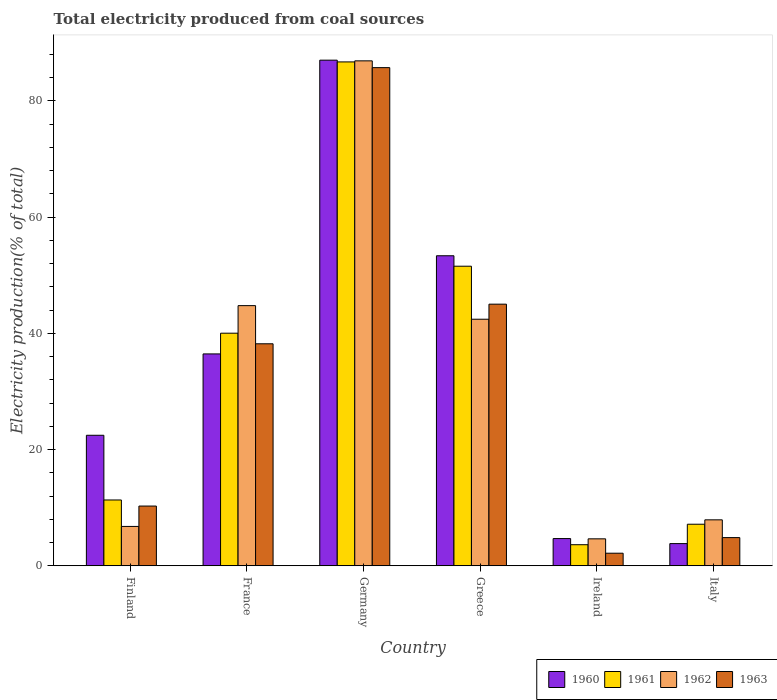What is the total electricity produced in 1962 in Germany?
Offer a terse response. 86.91. Across all countries, what is the maximum total electricity produced in 1962?
Provide a short and direct response. 86.91. Across all countries, what is the minimum total electricity produced in 1963?
Offer a terse response. 2.16. In which country was the total electricity produced in 1963 minimum?
Give a very brief answer. Ireland. What is the total total electricity produced in 1962 in the graph?
Offer a terse response. 193.45. What is the difference between the total electricity produced in 1962 in Finland and that in Ireland?
Offer a terse response. 2.13. What is the difference between the total electricity produced in 1963 in Ireland and the total electricity produced in 1962 in France?
Provide a short and direct response. -42.61. What is the average total electricity produced in 1961 per country?
Provide a succinct answer. 33.41. What is the difference between the total electricity produced of/in 1962 and total electricity produced of/in 1961 in France?
Offer a very short reply. 4.74. What is the ratio of the total electricity produced in 1960 in Germany to that in Italy?
Provide a succinct answer. 22.79. Is the difference between the total electricity produced in 1962 in Finland and Ireland greater than the difference between the total electricity produced in 1961 in Finland and Ireland?
Keep it short and to the point. No. What is the difference between the highest and the second highest total electricity produced in 1962?
Your answer should be very brief. -2.34. What is the difference between the highest and the lowest total electricity produced in 1963?
Provide a succinct answer. 83.58. In how many countries, is the total electricity produced in 1960 greater than the average total electricity produced in 1960 taken over all countries?
Offer a very short reply. 3. Is it the case that in every country, the sum of the total electricity produced in 1962 and total electricity produced in 1960 is greater than the sum of total electricity produced in 1963 and total electricity produced in 1961?
Make the answer very short. No. What does the 4th bar from the left in Germany represents?
Make the answer very short. 1963. Are all the bars in the graph horizontal?
Provide a succinct answer. No. What is the difference between two consecutive major ticks on the Y-axis?
Your response must be concise. 20. Does the graph contain grids?
Keep it short and to the point. No. How many legend labels are there?
Offer a terse response. 4. How are the legend labels stacked?
Offer a terse response. Horizontal. What is the title of the graph?
Ensure brevity in your answer.  Total electricity produced from coal sources. Does "1971" appear as one of the legend labels in the graph?
Make the answer very short. No. What is the label or title of the X-axis?
Provide a succinct answer. Country. What is the label or title of the Y-axis?
Your response must be concise. Electricity production(% of total). What is the Electricity production(% of total) of 1960 in Finland?
Your answer should be very brief. 22.46. What is the Electricity production(% of total) of 1961 in Finland?
Give a very brief answer. 11.33. What is the Electricity production(% of total) of 1962 in Finland?
Your answer should be compact. 6.78. What is the Electricity production(% of total) of 1963 in Finland?
Provide a succinct answer. 10.28. What is the Electricity production(% of total) in 1960 in France?
Keep it short and to the point. 36.47. What is the Electricity production(% of total) of 1961 in France?
Offer a very short reply. 40.03. What is the Electricity production(% of total) of 1962 in France?
Give a very brief answer. 44.78. What is the Electricity production(% of total) of 1963 in France?
Your response must be concise. 38.21. What is the Electricity production(% of total) of 1960 in Germany?
Your response must be concise. 87.03. What is the Electricity production(% of total) of 1961 in Germany?
Your answer should be compact. 86.73. What is the Electricity production(% of total) of 1962 in Germany?
Provide a short and direct response. 86.91. What is the Electricity production(% of total) of 1963 in Germany?
Your response must be concise. 85.74. What is the Electricity production(% of total) in 1960 in Greece?
Make the answer very short. 53.36. What is the Electricity production(% of total) in 1961 in Greece?
Your answer should be very brief. 51.56. What is the Electricity production(% of total) of 1962 in Greece?
Your response must be concise. 42.44. What is the Electricity production(% of total) in 1963 in Greece?
Keep it short and to the point. 45.03. What is the Electricity production(% of total) of 1960 in Ireland?
Ensure brevity in your answer.  4.69. What is the Electricity production(% of total) in 1961 in Ireland?
Offer a terse response. 3.63. What is the Electricity production(% of total) in 1962 in Ireland?
Ensure brevity in your answer.  4.64. What is the Electricity production(% of total) in 1963 in Ireland?
Give a very brief answer. 2.16. What is the Electricity production(% of total) in 1960 in Italy?
Offer a terse response. 3.82. What is the Electricity production(% of total) in 1961 in Italy?
Ensure brevity in your answer.  7.15. What is the Electricity production(% of total) of 1962 in Italy?
Provide a succinct answer. 7.91. What is the Electricity production(% of total) in 1963 in Italy?
Provide a succinct answer. 4.85. Across all countries, what is the maximum Electricity production(% of total) in 1960?
Your answer should be very brief. 87.03. Across all countries, what is the maximum Electricity production(% of total) of 1961?
Offer a terse response. 86.73. Across all countries, what is the maximum Electricity production(% of total) of 1962?
Offer a very short reply. 86.91. Across all countries, what is the maximum Electricity production(% of total) in 1963?
Provide a short and direct response. 85.74. Across all countries, what is the minimum Electricity production(% of total) of 1960?
Provide a succinct answer. 3.82. Across all countries, what is the minimum Electricity production(% of total) of 1961?
Keep it short and to the point. 3.63. Across all countries, what is the minimum Electricity production(% of total) in 1962?
Provide a succinct answer. 4.64. Across all countries, what is the minimum Electricity production(% of total) of 1963?
Provide a short and direct response. 2.16. What is the total Electricity production(% of total) of 1960 in the graph?
Provide a short and direct response. 207.83. What is the total Electricity production(% of total) in 1961 in the graph?
Offer a terse response. 200.43. What is the total Electricity production(% of total) of 1962 in the graph?
Keep it short and to the point. 193.45. What is the total Electricity production(% of total) of 1963 in the graph?
Provide a short and direct response. 186.28. What is the difference between the Electricity production(% of total) of 1960 in Finland and that in France?
Offer a very short reply. -14.01. What is the difference between the Electricity production(% of total) in 1961 in Finland and that in France?
Provide a succinct answer. -28.71. What is the difference between the Electricity production(% of total) in 1962 in Finland and that in France?
Make the answer very short. -38. What is the difference between the Electricity production(% of total) in 1963 in Finland and that in France?
Keep it short and to the point. -27.93. What is the difference between the Electricity production(% of total) in 1960 in Finland and that in Germany?
Ensure brevity in your answer.  -64.57. What is the difference between the Electricity production(% of total) in 1961 in Finland and that in Germany?
Your answer should be very brief. -75.4. What is the difference between the Electricity production(% of total) in 1962 in Finland and that in Germany?
Keep it short and to the point. -80.13. What is the difference between the Electricity production(% of total) in 1963 in Finland and that in Germany?
Provide a succinct answer. -75.46. What is the difference between the Electricity production(% of total) in 1960 in Finland and that in Greece?
Your answer should be compact. -30.9. What is the difference between the Electricity production(% of total) in 1961 in Finland and that in Greece?
Ensure brevity in your answer.  -40.24. What is the difference between the Electricity production(% of total) in 1962 in Finland and that in Greece?
Offer a very short reply. -35.66. What is the difference between the Electricity production(% of total) of 1963 in Finland and that in Greece?
Keep it short and to the point. -34.75. What is the difference between the Electricity production(% of total) of 1960 in Finland and that in Ireland?
Your response must be concise. 17.78. What is the difference between the Electricity production(% of total) of 1961 in Finland and that in Ireland?
Your answer should be compact. 7.7. What is the difference between the Electricity production(% of total) in 1962 in Finland and that in Ireland?
Your answer should be very brief. 2.13. What is the difference between the Electricity production(% of total) of 1963 in Finland and that in Ireland?
Your answer should be very brief. 8.12. What is the difference between the Electricity production(% of total) in 1960 in Finland and that in Italy?
Your response must be concise. 18.65. What is the difference between the Electricity production(% of total) of 1961 in Finland and that in Italy?
Ensure brevity in your answer.  4.17. What is the difference between the Electricity production(% of total) of 1962 in Finland and that in Italy?
Your answer should be compact. -1.13. What is the difference between the Electricity production(% of total) of 1963 in Finland and that in Italy?
Your response must be concise. 5.43. What is the difference between the Electricity production(% of total) in 1960 in France and that in Germany?
Ensure brevity in your answer.  -50.56. What is the difference between the Electricity production(% of total) of 1961 in France and that in Germany?
Your answer should be compact. -46.69. What is the difference between the Electricity production(% of total) in 1962 in France and that in Germany?
Your answer should be very brief. -42.13. What is the difference between the Electricity production(% of total) in 1963 in France and that in Germany?
Give a very brief answer. -47.53. What is the difference between the Electricity production(% of total) in 1960 in France and that in Greece?
Your answer should be very brief. -16.89. What is the difference between the Electricity production(% of total) of 1961 in France and that in Greece?
Give a very brief answer. -11.53. What is the difference between the Electricity production(% of total) in 1962 in France and that in Greece?
Keep it short and to the point. 2.34. What is the difference between the Electricity production(% of total) in 1963 in France and that in Greece?
Your response must be concise. -6.82. What is the difference between the Electricity production(% of total) of 1960 in France and that in Ireland?
Make the answer very short. 31.78. What is the difference between the Electricity production(% of total) in 1961 in France and that in Ireland?
Your answer should be compact. 36.41. What is the difference between the Electricity production(% of total) of 1962 in France and that in Ireland?
Offer a terse response. 40.14. What is the difference between the Electricity production(% of total) in 1963 in France and that in Ireland?
Your answer should be compact. 36.05. What is the difference between the Electricity production(% of total) in 1960 in France and that in Italy?
Keep it short and to the point. 32.65. What is the difference between the Electricity production(% of total) of 1961 in France and that in Italy?
Your answer should be compact. 32.88. What is the difference between the Electricity production(% of total) in 1962 in France and that in Italy?
Ensure brevity in your answer.  36.87. What is the difference between the Electricity production(% of total) in 1963 in France and that in Italy?
Give a very brief answer. 33.36. What is the difference between the Electricity production(% of total) in 1960 in Germany and that in Greece?
Give a very brief answer. 33.67. What is the difference between the Electricity production(% of total) of 1961 in Germany and that in Greece?
Provide a succinct answer. 35.16. What is the difference between the Electricity production(% of total) in 1962 in Germany and that in Greece?
Offer a terse response. 44.47. What is the difference between the Electricity production(% of total) in 1963 in Germany and that in Greece?
Your response must be concise. 40.71. What is the difference between the Electricity production(% of total) of 1960 in Germany and that in Ireland?
Offer a very short reply. 82.34. What is the difference between the Electricity production(% of total) in 1961 in Germany and that in Ireland?
Offer a very short reply. 83.1. What is the difference between the Electricity production(% of total) in 1962 in Germany and that in Ireland?
Give a very brief answer. 82.27. What is the difference between the Electricity production(% of total) in 1963 in Germany and that in Ireland?
Ensure brevity in your answer.  83.58. What is the difference between the Electricity production(% of total) in 1960 in Germany and that in Italy?
Keep it short and to the point. 83.21. What is the difference between the Electricity production(% of total) in 1961 in Germany and that in Italy?
Offer a terse response. 79.57. What is the difference between the Electricity production(% of total) in 1962 in Germany and that in Italy?
Offer a very short reply. 79. What is the difference between the Electricity production(% of total) in 1963 in Germany and that in Italy?
Provide a succinct answer. 80.89. What is the difference between the Electricity production(% of total) in 1960 in Greece and that in Ireland?
Offer a terse response. 48.68. What is the difference between the Electricity production(% of total) in 1961 in Greece and that in Ireland?
Your response must be concise. 47.93. What is the difference between the Electricity production(% of total) in 1962 in Greece and that in Ireland?
Provide a succinct answer. 37.8. What is the difference between the Electricity production(% of total) of 1963 in Greece and that in Ireland?
Ensure brevity in your answer.  42.87. What is the difference between the Electricity production(% of total) in 1960 in Greece and that in Italy?
Offer a very short reply. 49.54. What is the difference between the Electricity production(% of total) in 1961 in Greece and that in Italy?
Give a very brief answer. 44.41. What is the difference between the Electricity production(% of total) in 1962 in Greece and that in Italy?
Ensure brevity in your answer.  34.53. What is the difference between the Electricity production(% of total) in 1963 in Greece and that in Italy?
Give a very brief answer. 40.18. What is the difference between the Electricity production(% of total) of 1960 in Ireland and that in Italy?
Provide a succinct answer. 0.87. What is the difference between the Electricity production(% of total) of 1961 in Ireland and that in Italy?
Give a very brief answer. -3.53. What is the difference between the Electricity production(% of total) of 1962 in Ireland and that in Italy?
Give a very brief answer. -3.27. What is the difference between the Electricity production(% of total) in 1963 in Ireland and that in Italy?
Ensure brevity in your answer.  -2.69. What is the difference between the Electricity production(% of total) of 1960 in Finland and the Electricity production(% of total) of 1961 in France?
Provide a succinct answer. -17.57. What is the difference between the Electricity production(% of total) in 1960 in Finland and the Electricity production(% of total) in 1962 in France?
Make the answer very short. -22.31. What is the difference between the Electricity production(% of total) of 1960 in Finland and the Electricity production(% of total) of 1963 in France?
Your response must be concise. -15.75. What is the difference between the Electricity production(% of total) of 1961 in Finland and the Electricity production(% of total) of 1962 in France?
Give a very brief answer. -33.45. What is the difference between the Electricity production(% of total) of 1961 in Finland and the Electricity production(% of total) of 1963 in France?
Keep it short and to the point. -26.88. What is the difference between the Electricity production(% of total) in 1962 in Finland and the Electricity production(% of total) in 1963 in France?
Your answer should be compact. -31.44. What is the difference between the Electricity production(% of total) in 1960 in Finland and the Electricity production(% of total) in 1961 in Germany?
Provide a short and direct response. -64.26. What is the difference between the Electricity production(% of total) in 1960 in Finland and the Electricity production(% of total) in 1962 in Germany?
Provide a succinct answer. -64.45. What is the difference between the Electricity production(% of total) in 1960 in Finland and the Electricity production(% of total) in 1963 in Germany?
Ensure brevity in your answer.  -63.28. What is the difference between the Electricity production(% of total) of 1961 in Finland and the Electricity production(% of total) of 1962 in Germany?
Your answer should be very brief. -75.58. What is the difference between the Electricity production(% of total) of 1961 in Finland and the Electricity production(% of total) of 1963 in Germany?
Offer a terse response. -74.41. What is the difference between the Electricity production(% of total) in 1962 in Finland and the Electricity production(% of total) in 1963 in Germany?
Offer a very short reply. -78.97. What is the difference between the Electricity production(% of total) of 1960 in Finland and the Electricity production(% of total) of 1961 in Greece?
Your response must be concise. -29.1. What is the difference between the Electricity production(% of total) in 1960 in Finland and the Electricity production(% of total) in 1962 in Greece?
Give a very brief answer. -19.98. What is the difference between the Electricity production(% of total) in 1960 in Finland and the Electricity production(% of total) in 1963 in Greece?
Provide a short and direct response. -22.57. What is the difference between the Electricity production(% of total) of 1961 in Finland and the Electricity production(% of total) of 1962 in Greece?
Your answer should be very brief. -31.11. What is the difference between the Electricity production(% of total) of 1961 in Finland and the Electricity production(% of total) of 1963 in Greece?
Your response must be concise. -33.7. What is the difference between the Electricity production(% of total) in 1962 in Finland and the Electricity production(% of total) in 1963 in Greece?
Your answer should be compact. -38.26. What is the difference between the Electricity production(% of total) in 1960 in Finland and the Electricity production(% of total) in 1961 in Ireland?
Your response must be concise. 18.84. What is the difference between the Electricity production(% of total) of 1960 in Finland and the Electricity production(% of total) of 1962 in Ireland?
Your answer should be compact. 17.82. What is the difference between the Electricity production(% of total) in 1960 in Finland and the Electricity production(% of total) in 1963 in Ireland?
Provide a short and direct response. 20.3. What is the difference between the Electricity production(% of total) of 1961 in Finland and the Electricity production(% of total) of 1962 in Ireland?
Your answer should be compact. 6.69. What is the difference between the Electricity production(% of total) of 1961 in Finland and the Electricity production(% of total) of 1963 in Ireland?
Your answer should be very brief. 9.16. What is the difference between the Electricity production(% of total) in 1962 in Finland and the Electricity production(% of total) in 1963 in Ireland?
Give a very brief answer. 4.61. What is the difference between the Electricity production(% of total) in 1960 in Finland and the Electricity production(% of total) in 1961 in Italy?
Your answer should be compact. 15.31. What is the difference between the Electricity production(% of total) in 1960 in Finland and the Electricity production(% of total) in 1962 in Italy?
Keep it short and to the point. 14.55. What is the difference between the Electricity production(% of total) in 1960 in Finland and the Electricity production(% of total) in 1963 in Italy?
Provide a succinct answer. 17.61. What is the difference between the Electricity production(% of total) of 1961 in Finland and the Electricity production(% of total) of 1962 in Italy?
Provide a succinct answer. 3.42. What is the difference between the Electricity production(% of total) in 1961 in Finland and the Electricity production(% of total) in 1963 in Italy?
Provide a succinct answer. 6.48. What is the difference between the Electricity production(% of total) in 1962 in Finland and the Electricity production(% of total) in 1963 in Italy?
Offer a terse response. 1.92. What is the difference between the Electricity production(% of total) of 1960 in France and the Electricity production(% of total) of 1961 in Germany?
Provide a short and direct response. -50.26. What is the difference between the Electricity production(% of total) in 1960 in France and the Electricity production(% of total) in 1962 in Germany?
Your answer should be compact. -50.44. What is the difference between the Electricity production(% of total) in 1960 in France and the Electricity production(% of total) in 1963 in Germany?
Make the answer very short. -49.27. What is the difference between the Electricity production(% of total) of 1961 in France and the Electricity production(% of total) of 1962 in Germany?
Offer a terse response. -46.87. What is the difference between the Electricity production(% of total) of 1961 in France and the Electricity production(% of total) of 1963 in Germany?
Your answer should be very brief. -45.71. What is the difference between the Electricity production(% of total) of 1962 in France and the Electricity production(% of total) of 1963 in Germany?
Offer a very short reply. -40.97. What is the difference between the Electricity production(% of total) in 1960 in France and the Electricity production(% of total) in 1961 in Greece?
Provide a succinct answer. -15.09. What is the difference between the Electricity production(% of total) in 1960 in France and the Electricity production(% of total) in 1962 in Greece?
Give a very brief answer. -5.97. What is the difference between the Electricity production(% of total) in 1960 in France and the Electricity production(% of total) in 1963 in Greece?
Provide a short and direct response. -8.56. What is the difference between the Electricity production(% of total) of 1961 in France and the Electricity production(% of total) of 1962 in Greece?
Give a very brief answer. -2.41. What is the difference between the Electricity production(% of total) of 1961 in France and the Electricity production(% of total) of 1963 in Greece?
Offer a very short reply. -5. What is the difference between the Electricity production(% of total) in 1962 in France and the Electricity production(% of total) in 1963 in Greece?
Ensure brevity in your answer.  -0.25. What is the difference between the Electricity production(% of total) in 1960 in France and the Electricity production(% of total) in 1961 in Ireland?
Your answer should be very brief. 32.84. What is the difference between the Electricity production(% of total) of 1960 in France and the Electricity production(% of total) of 1962 in Ireland?
Make the answer very short. 31.83. What is the difference between the Electricity production(% of total) of 1960 in France and the Electricity production(% of total) of 1963 in Ireland?
Give a very brief answer. 34.3. What is the difference between the Electricity production(% of total) in 1961 in France and the Electricity production(% of total) in 1962 in Ireland?
Keep it short and to the point. 35.39. What is the difference between the Electricity production(% of total) in 1961 in France and the Electricity production(% of total) in 1963 in Ireland?
Your answer should be very brief. 37.87. What is the difference between the Electricity production(% of total) of 1962 in France and the Electricity production(% of total) of 1963 in Ireland?
Offer a terse response. 42.61. What is the difference between the Electricity production(% of total) of 1960 in France and the Electricity production(% of total) of 1961 in Italy?
Your answer should be very brief. 29.31. What is the difference between the Electricity production(% of total) in 1960 in France and the Electricity production(% of total) in 1962 in Italy?
Make the answer very short. 28.56. What is the difference between the Electricity production(% of total) in 1960 in France and the Electricity production(% of total) in 1963 in Italy?
Keep it short and to the point. 31.62. What is the difference between the Electricity production(% of total) of 1961 in France and the Electricity production(% of total) of 1962 in Italy?
Offer a very short reply. 32.13. What is the difference between the Electricity production(% of total) of 1961 in France and the Electricity production(% of total) of 1963 in Italy?
Provide a succinct answer. 35.18. What is the difference between the Electricity production(% of total) in 1962 in France and the Electricity production(% of total) in 1963 in Italy?
Offer a very short reply. 39.93. What is the difference between the Electricity production(% of total) of 1960 in Germany and the Electricity production(% of total) of 1961 in Greece?
Offer a very short reply. 35.47. What is the difference between the Electricity production(% of total) of 1960 in Germany and the Electricity production(% of total) of 1962 in Greece?
Provide a short and direct response. 44.59. What is the difference between the Electricity production(% of total) of 1960 in Germany and the Electricity production(% of total) of 1963 in Greece?
Keep it short and to the point. 42. What is the difference between the Electricity production(% of total) in 1961 in Germany and the Electricity production(% of total) in 1962 in Greece?
Keep it short and to the point. 44.29. What is the difference between the Electricity production(% of total) of 1961 in Germany and the Electricity production(% of total) of 1963 in Greece?
Your response must be concise. 41.69. What is the difference between the Electricity production(% of total) of 1962 in Germany and the Electricity production(% of total) of 1963 in Greece?
Offer a very short reply. 41.88. What is the difference between the Electricity production(% of total) in 1960 in Germany and the Electricity production(% of total) in 1961 in Ireland?
Keep it short and to the point. 83.4. What is the difference between the Electricity production(% of total) in 1960 in Germany and the Electricity production(% of total) in 1962 in Ireland?
Ensure brevity in your answer.  82.39. What is the difference between the Electricity production(% of total) of 1960 in Germany and the Electricity production(% of total) of 1963 in Ireland?
Provide a short and direct response. 84.86. What is the difference between the Electricity production(% of total) of 1961 in Germany and the Electricity production(% of total) of 1962 in Ireland?
Your response must be concise. 82.08. What is the difference between the Electricity production(% of total) in 1961 in Germany and the Electricity production(% of total) in 1963 in Ireland?
Offer a terse response. 84.56. What is the difference between the Electricity production(% of total) of 1962 in Germany and the Electricity production(% of total) of 1963 in Ireland?
Your answer should be very brief. 84.74. What is the difference between the Electricity production(% of total) of 1960 in Germany and the Electricity production(% of total) of 1961 in Italy?
Provide a short and direct response. 79.87. What is the difference between the Electricity production(% of total) of 1960 in Germany and the Electricity production(% of total) of 1962 in Italy?
Make the answer very short. 79.12. What is the difference between the Electricity production(% of total) in 1960 in Germany and the Electricity production(% of total) in 1963 in Italy?
Keep it short and to the point. 82.18. What is the difference between the Electricity production(% of total) in 1961 in Germany and the Electricity production(% of total) in 1962 in Italy?
Provide a succinct answer. 78.82. What is the difference between the Electricity production(% of total) in 1961 in Germany and the Electricity production(% of total) in 1963 in Italy?
Keep it short and to the point. 81.87. What is the difference between the Electricity production(% of total) in 1962 in Germany and the Electricity production(% of total) in 1963 in Italy?
Keep it short and to the point. 82.06. What is the difference between the Electricity production(% of total) of 1960 in Greece and the Electricity production(% of total) of 1961 in Ireland?
Your answer should be compact. 49.73. What is the difference between the Electricity production(% of total) of 1960 in Greece and the Electricity production(% of total) of 1962 in Ireland?
Ensure brevity in your answer.  48.72. What is the difference between the Electricity production(% of total) of 1960 in Greece and the Electricity production(% of total) of 1963 in Ireland?
Provide a succinct answer. 51.2. What is the difference between the Electricity production(% of total) of 1961 in Greece and the Electricity production(% of total) of 1962 in Ireland?
Your answer should be compact. 46.92. What is the difference between the Electricity production(% of total) of 1961 in Greece and the Electricity production(% of total) of 1963 in Ireland?
Keep it short and to the point. 49.4. What is the difference between the Electricity production(% of total) of 1962 in Greece and the Electricity production(% of total) of 1963 in Ireland?
Offer a very short reply. 40.27. What is the difference between the Electricity production(% of total) of 1960 in Greece and the Electricity production(% of total) of 1961 in Italy?
Your answer should be compact. 46.21. What is the difference between the Electricity production(% of total) in 1960 in Greece and the Electricity production(% of total) in 1962 in Italy?
Give a very brief answer. 45.45. What is the difference between the Electricity production(% of total) in 1960 in Greece and the Electricity production(% of total) in 1963 in Italy?
Offer a terse response. 48.51. What is the difference between the Electricity production(% of total) in 1961 in Greece and the Electricity production(% of total) in 1962 in Italy?
Offer a very short reply. 43.65. What is the difference between the Electricity production(% of total) of 1961 in Greece and the Electricity production(% of total) of 1963 in Italy?
Provide a succinct answer. 46.71. What is the difference between the Electricity production(% of total) of 1962 in Greece and the Electricity production(% of total) of 1963 in Italy?
Provide a succinct answer. 37.59. What is the difference between the Electricity production(% of total) in 1960 in Ireland and the Electricity production(% of total) in 1961 in Italy?
Your answer should be very brief. -2.47. What is the difference between the Electricity production(% of total) in 1960 in Ireland and the Electricity production(% of total) in 1962 in Italy?
Your answer should be very brief. -3.22. What is the difference between the Electricity production(% of total) of 1960 in Ireland and the Electricity production(% of total) of 1963 in Italy?
Offer a very short reply. -0.17. What is the difference between the Electricity production(% of total) of 1961 in Ireland and the Electricity production(% of total) of 1962 in Italy?
Your response must be concise. -4.28. What is the difference between the Electricity production(% of total) of 1961 in Ireland and the Electricity production(% of total) of 1963 in Italy?
Keep it short and to the point. -1.22. What is the difference between the Electricity production(% of total) in 1962 in Ireland and the Electricity production(% of total) in 1963 in Italy?
Your answer should be compact. -0.21. What is the average Electricity production(% of total) in 1960 per country?
Offer a terse response. 34.64. What is the average Electricity production(% of total) in 1961 per country?
Make the answer very short. 33.41. What is the average Electricity production(% of total) in 1962 per country?
Your answer should be compact. 32.24. What is the average Electricity production(% of total) of 1963 per country?
Provide a short and direct response. 31.05. What is the difference between the Electricity production(% of total) in 1960 and Electricity production(% of total) in 1961 in Finland?
Ensure brevity in your answer.  11.14. What is the difference between the Electricity production(% of total) of 1960 and Electricity production(% of total) of 1962 in Finland?
Ensure brevity in your answer.  15.69. What is the difference between the Electricity production(% of total) of 1960 and Electricity production(% of total) of 1963 in Finland?
Your answer should be very brief. 12.18. What is the difference between the Electricity production(% of total) of 1961 and Electricity production(% of total) of 1962 in Finland?
Your answer should be very brief. 4.55. What is the difference between the Electricity production(% of total) of 1961 and Electricity production(% of total) of 1963 in Finland?
Offer a very short reply. 1.04. What is the difference between the Electricity production(% of total) in 1962 and Electricity production(% of total) in 1963 in Finland?
Your response must be concise. -3.51. What is the difference between the Electricity production(% of total) of 1960 and Electricity production(% of total) of 1961 in France?
Give a very brief answer. -3.57. What is the difference between the Electricity production(% of total) in 1960 and Electricity production(% of total) in 1962 in France?
Ensure brevity in your answer.  -8.31. What is the difference between the Electricity production(% of total) of 1960 and Electricity production(% of total) of 1963 in France?
Make the answer very short. -1.74. What is the difference between the Electricity production(% of total) in 1961 and Electricity production(% of total) in 1962 in France?
Give a very brief answer. -4.74. What is the difference between the Electricity production(% of total) of 1961 and Electricity production(% of total) of 1963 in France?
Ensure brevity in your answer.  1.82. What is the difference between the Electricity production(% of total) in 1962 and Electricity production(% of total) in 1963 in France?
Give a very brief answer. 6.57. What is the difference between the Electricity production(% of total) of 1960 and Electricity production(% of total) of 1961 in Germany?
Provide a succinct answer. 0.3. What is the difference between the Electricity production(% of total) in 1960 and Electricity production(% of total) in 1962 in Germany?
Give a very brief answer. 0.12. What is the difference between the Electricity production(% of total) of 1960 and Electricity production(% of total) of 1963 in Germany?
Offer a terse response. 1.29. What is the difference between the Electricity production(% of total) in 1961 and Electricity production(% of total) in 1962 in Germany?
Your answer should be compact. -0.18. What is the difference between the Electricity production(% of total) in 1961 and Electricity production(% of total) in 1963 in Germany?
Your response must be concise. 0.98. What is the difference between the Electricity production(% of total) of 1962 and Electricity production(% of total) of 1963 in Germany?
Ensure brevity in your answer.  1.17. What is the difference between the Electricity production(% of total) in 1960 and Electricity production(% of total) in 1961 in Greece?
Give a very brief answer. 1.8. What is the difference between the Electricity production(% of total) in 1960 and Electricity production(% of total) in 1962 in Greece?
Your answer should be very brief. 10.92. What is the difference between the Electricity production(% of total) in 1960 and Electricity production(% of total) in 1963 in Greece?
Make the answer very short. 8.33. What is the difference between the Electricity production(% of total) in 1961 and Electricity production(% of total) in 1962 in Greece?
Your answer should be very brief. 9.12. What is the difference between the Electricity production(% of total) in 1961 and Electricity production(% of total) in 1963 in Greece?
Provide a succinct answer. 6.53. What is the difference between the Electricity production(% of total) of 1962 and Electricity production(% of total) of 1963 in Greece?
Provide a short and direct response. -2.59. What is the difference between the Electricity production(% of total) in 1960 and Electricity production(% of total) in 1961 in Ireland?
Offer a very short reply. 1.06. What is the difference between the Electricity production(% of total) in 1960 and Electricity production(% of total) in 1962 in Ireland?
Provide a succinct answer. 0.05. What is the difference between the Electricity production(% of total) in 1960 and Electricity production(% of total) in 1963 in Ireland?
Your answer should be very brief. 2.52. What is the difference between the Electricity production(% of total) of 1961 and Electricity production(% of total) of 1962 in Ireland?
Ensure brevity in your answer.  -1.01. What is the difference between the Electricity production(% of total) in 1961 and Electricity production(% of total) in 1963 in Ireland?
Your answer should be very brief. 1.46. What is the difference between the Electricity production(% of total) of 1962 and Electricity production(% of total) of 1963 in Ireland?
Give a very brief answer. 2.48. What is the difference between the Electricity production(% of total) of 1960 and Electricity production(% of total) of 1961 in Italy?
Your response must be concise. -3.34. What is the difference between the Electricity production(% of total) in 1960 and Electricity production(% of total) in 1962 in Italy?
Ensure brevity in your answer.  -4.09. What is the difference between the Electricity production(% of total) of 1960 and Electricity production(% of total) of 1963 in Italy?
Offer a terse response. -1.03. What is the difference between the Electricity production(% of total) in 1961 and Electricity production(% of total) in 1962 in Italy?
Provide a short and direct response. -0.75. What is the difference between the Electricity production(% of total) of 1961 and Electricity production(% of total) of 1963 in Italy?
Ensure brevity in your answer.  2.3. What is the difference between the Electricity production(% of total) in 1962 and Electricity production(% of total) in 1963 in Italy?
Ensure brevity in your answer.  3.06. What is the ratio of the Electricity production(% of total) of 1960 in Finland to that in France?
Give a very brief answer. 0.62. What is the ratio of the Electricity production(% of total) of 1961 in Finland to that in France?
Your response must be concise. 0.28. What is the ratio of the Electricity production(% of total) in 1962 in Finland to that in France?
Provide a short and direct response. 0.15. What is the ratio of the Electricity production(% of total) in 1963 in Finland to that in France?
Provide a succinct answer. 0.27. What is the ratio of the Electricity production(% of total) of 1960 in Finland to that in Germany?
Your answer should be very brief. 0.26. What is the ratio of the Electricity production(% of total) in 1961 in Finland to that in Germany?
Ensure brevity in your answer.  0.13. What is the ratio of the Electricity production(% of total) of 1962 in Finland to that in Germany?
Give a very brief answer. 0.08. What is the ratio of the Electricity production(% of total) of 1963 in Finland to that in Germany?
Your answer should be compact. 0.12. What is the ratio of the Electricity production(% of total) of 1960 in Finland to that in Greece?
Offer a terse response. 0.42. What is the ratio of the Electricity production(% of total) of 1961 in Finland to that in Greece?
Your answer should be very brief. 0.22. What is the ratio of the Electricity production(% of total) of 1962 in Finland to that in Greece?
Give a very brief answer. 0.16. What is the ratio of the Electricity production(% of total) of 1963 in Finland to that in Greece?
Provide a succinct answer. 0.23. What is the ratio of the Electricity production(% of total) in 1960 in Finland to that in Ireland?
Ensure brevity in your answer.  4.79. What is the ratio of the Electricity production(% of total) in 1961 in Finland to that in Ireland?
Keep it short and to the point. 3.12. What is the ratio of the Electricity production(% of total) of 1962 in Finland to that in Ireland?
Give a very brief answer. 1.46. What is the ratio of the Electricity production(% of total) in 1963 in Finland to that in Ireland?
Provide a succinct answer. 4.75. What is the ratio of the Electricity production(% of total) of 1960 in Finland to that in Italy?
Provide a short and direct response. 5.88. What is the ratio of the Electricity production(% of total) of 1961 in Finland to that in Italy?
Ensure brevity in your answer.  1.58. What is the ratio of the Electricity production(% of total) in 1962 in Finland to that in Italy?
Make the answer very short. 0.86. What is the ratio of the Electricity production(% of total) of 1963 in Finland to that in Italy?
Your answer should be very brief. 2.12. What is the ratio of the Electricity production(% of total) in 1960 in France to that in Germany?
Offer a terse response. 0.42. What is the ratio of the Electricity production(% of total) of 1961 in France to that in Germany?
Provide a succinct answer. 0.46. What is the ratio of the Electricity production(% of total) of 1962 in France to that in Germany?
Your answer should be very brief. 0.52. What is the ratio of the Electricity production(% of total) in 1963 in France to that in Germany?
Keep it short and to the point. 0.45. What is the ratio of the Electricity production(% of total) of 1960 in France to that in Greece?
Your answer should be compact. 0.68. What is the ratio of the Electricity production(% of total) of 1961 in France to that in Greece?
Your answer should be compact. 0.78. What is the ratio of the Electricity production(% of total) of 1962 in France to that in Greece?
Ensure brevity in your answer.  1.06. What is the ratio of the Electricity production(% of total) in 1963 in France to that in Greece?
Your answer should be compact. 0.85. What is the ratio of the Electricity production(% of total) in 1960 in France to that in Ireland?
Your answer should be very brief. 7.78. What is the ratio of the Electricity production(% of total) in 1961 in France to that in Ireland?
Your answer should be compact. 11.03. What is the ratio of the Electricity production(% of total) of 1962 in France to that in Ireland?
Keep it short and to the point. 9.65. What is the ratio of the Electricity production(% of total) in 1963 in France to that in Ireland?
Offer a terse response. 17.65. What is the ratio of the Electricity production(% of total) of 1960 in France to that in Italy?
Keep it short and to the point. 9.55. What is the ratio of the Electricity production(% of total) in 1961 in France to that in Italy?
Your response must be concise. 5.6. What is the ratio of the Electricity production(% of total) of 1962 in France to that in Italy?
Keep it short and to the point. 5.66. What is the ratio of the Electricity production(% of total) in 1963 in France to that in Italy?
Offer a very short reply. 7.88. What is the ratio of the Electricity production(% of total) in 1960 in Germany to that in Greece?
Your answer should be compact. 1.63. What is the ratio of the Electricity production(% of total) of 1961 in Germany to that in Greece?
Your answer should be very brief. 1.68. What is the ratio of the Electricity production(% of total) in 1962 in Germany to that in Greece?
Give a very brief answer. 2.05. What is the ratio of the Electricity production(% of total) in 1963 in Germany to that in Greece?
Ensure brevity in your answer.  1.9. What is the ratio of the Electricity production(% of total) in 1960 in Germany to that in Ireland?
Offer a very short reply. 18.57. What is the ratio of the Electricity production(% of total) in 1961 in Germany to that in Ireland?
Make the answer very short. 23.9. What is the ratio of the Electricity production(% of total) in 1962 in Germany to that in Ireland?
Your response must be concise. 18.73. What is the ratio of the Electricity production(% of total) of 1963 in Germany to that in Ireland?
Your answer should be very brief. 39.6. What is the ratio of the Electricity production(% of total) in 1960 in Germany to that in Italy?
Provide a succinct answer. 22.79. What is the ratio of the Electricity production(% of total) of 1961 in Germany to that in Italy?
Provide a succinct answer. 12.12. What is the ratio of the Electricity production(% of total) in 1962 in Germany to that in Italy?
Ensure brevity in your answer.  10.99. What is the ratio of the Electricity production(% of total) in 1963 in Germany to that in Italy?
Provide a succinct answer. 17.67. What is the ratio of the Electricity production(% of total) in 1960 in Greece to that in Ireland?
Your answer should be compact. 11.39. What is the ratio of the Electricity production(% of total) in 1961 in Greece to that in Ireland?
Offer a terse response. 14.21. What is the ratio of the Electricity production(% of total) in 1962 in Greece to that in Ireland?
Offer a terse response. 9.14. What is the ratio of the Electricity production(% of total) in 1963 in Greece to that in Ireland?
Keep it short and to the point. 20.8. What is the ratio of the Electricity production(% of total) of 1960 in Greece to that in Italy?
Ensure brevity in your answer.  13.97. What is the ratio of the Electricity production(% of total) in 1961 in Greece to that in Italy?
Provide a short and direct response. 7.21. What is the ratio of the Electricity production(% of total) of 1962 in Greece to that in Italy?
Make the answer very short. 5.37. What is the ratio of the Electricity production(% of total) of 1963 in Greece to that in Italy?
Make the answer very short. 9.28. What is the ratio of the Electricity production(% of total) of 1960 in Ireland to that in Italy?
Provide a succinct answer. 1.23. What is the ratio of the Electricity production(% of total) of 1961 in Ireland to that in Italy?
Provide a short and direct response. 0.51. What is the ratio of the Electricity production(% of total) of 1962 in Ireland to that in Italy?
Offer a very short reply. 0.59. What is the ratio of the Electricity production(% of total) of 1963 in Ireland to that in Italy?
Your answer should be very brief. 0.45. What is the difference between the highest and the second highest Electricity production(% of total) of 1960?
Provide a short and direct response. 33.67. What is the difference between the highest and the second highest Electricity production(% of total) of 1961?
Provide a short and direct response. 35.16. What is the difference between the highest and the second highest Electricity production(% of total) in 1962?
Offer a terse response. 42.13. What is the difference between the highest and the second highest Electricity production(% of total) in 1963?
Offer a very short reply. 40.71. What is the difference between the highest and the lowest Electricity production(% of total) in 1960?
Your response must be concise. 83.21. What is the difference between the highest and the lowest Electricity production(% of total) in 1961?
Offer a very short reply. 83.1. What is the difference between the highest and the lowest Electricity production(% of total) of 1962?
Your answer should be compact. 82.27. What is the difference between the highest and the lowest Electricity production(% of total) in 1963?
Give a very brief answer. 83.58. 